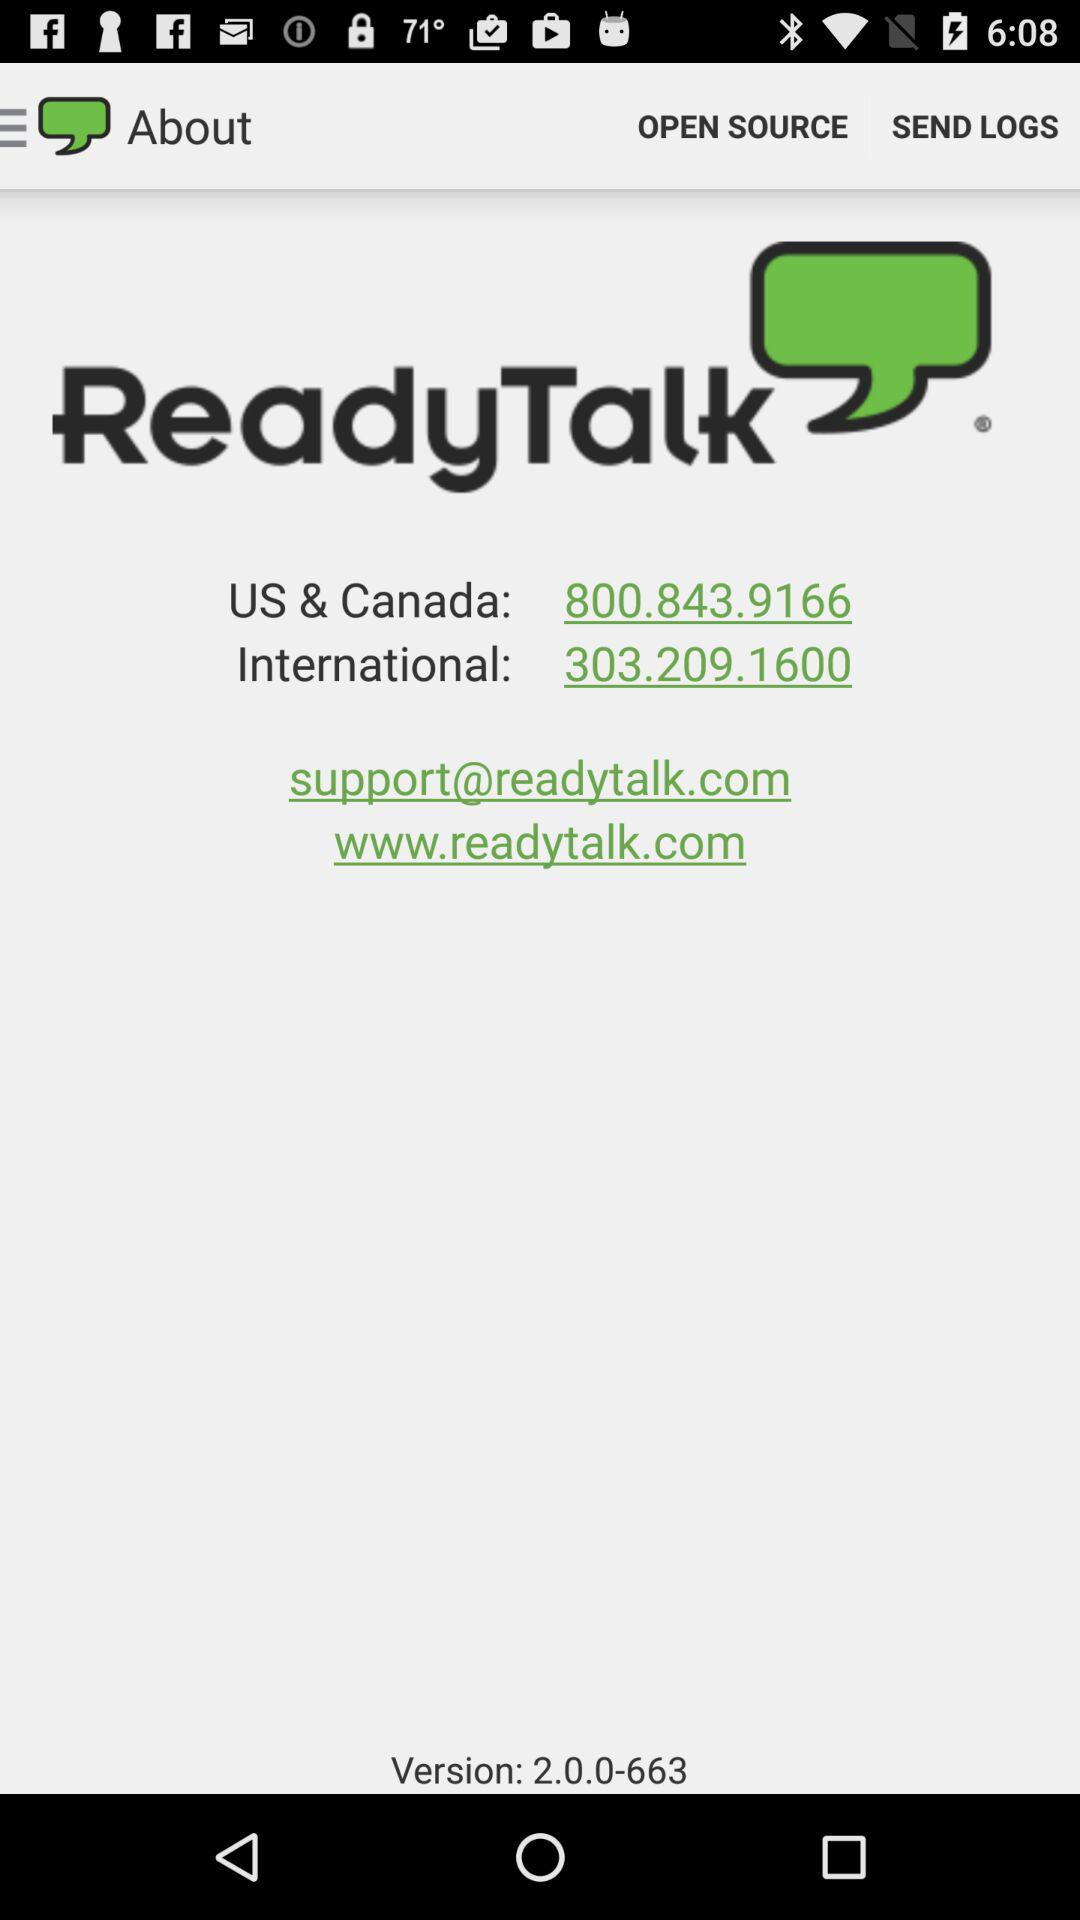Which version is given? The given version is 2.0.0-663. 